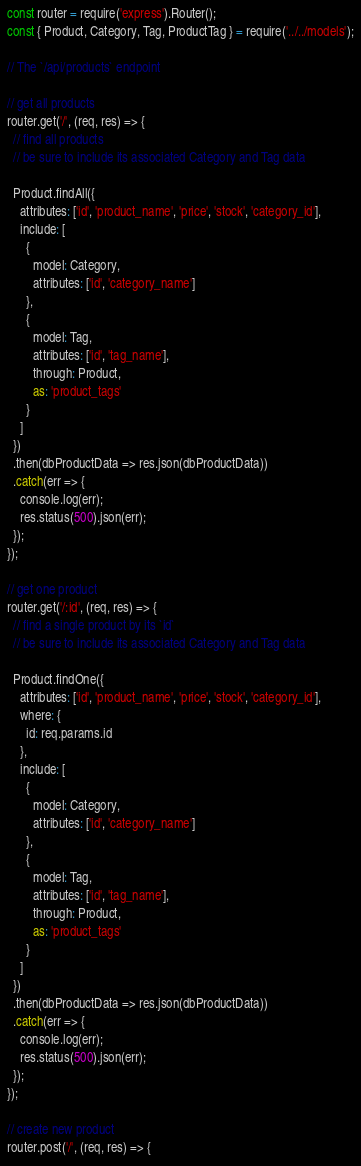Convert code to text. <code><loc_0><loc_0><loc_500><loc_500><_JavaScript_>const router = require('express').Router();
const { Product, Category, Tag, ProductTag } = require('../../models');

// The `/api/products` endpoint

// get all products
router.get('/', (req, res) => {
  // find all products
  // be sure to include its associated Category and Tag data

  Product.findAll({
    attributes: ['id', 'product_name', 'price', 'stock', 'category_id'],
    include: [
      {
        model: Category,
        attributes: ['id', 'category_name']
      },
      {
        model: Tag,
        attributes: ['id', 'tag_name'],
        through: Product,
        as: 'product_tags'
      }
    ]
  })
  .then(dbProductData => res.json(dbProductData))
  .catch(err => {
    console.log(err);
    res.status(500).json(err);
  });
});

// get one product
router.get('/:id', (req, res) => {
  // find a single product by its `id`
  // be sure to include its associated Category and Tag data

  Product.findOne({
    attributes: ['id', 'product_name', 'price', 'stock', 'category_id'],
    where: {
      id: req.params.id
    },
    include: [
      {
        model: Category,
        attributes: ['id', 'category_name']
      },
      {
        model: Tag,
        attributes: ['id', 'tag_name'],
        through: Product,
        as: 'product_tags'
      }
    ]
  })
  .then(dbProductData => res.json(dbProductData))
  .catch(err => {
    console.log(err);
    res.status(500).json(err);
  });
});

// create new product
router.post('/', (req, res) => {</code> 